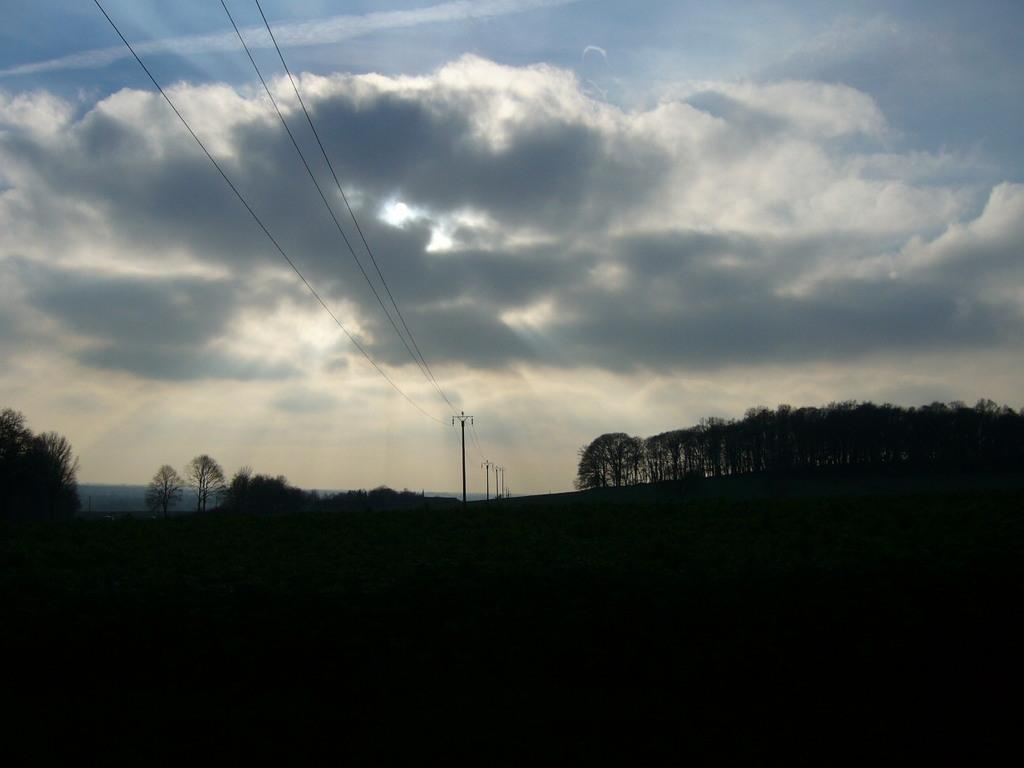What type of vegetation is at the bottom of the image? There are trees at the bottom of the image. What else can be seen at the bottom of the image? There are poles at the bottom of the image. What is visible in the background of the image? There are mountains in the background of the image. What is present in the center of the image? There are poles and wires in the center of the image. What is visible at the top of the image? The sky is visible at the top of the image. How many dust particles can be seen on the poles in the image? There is no information about dust particles in the image, so it is impossible to determine their number. Are there any bears visible in the image? There are no bears present in the image. 